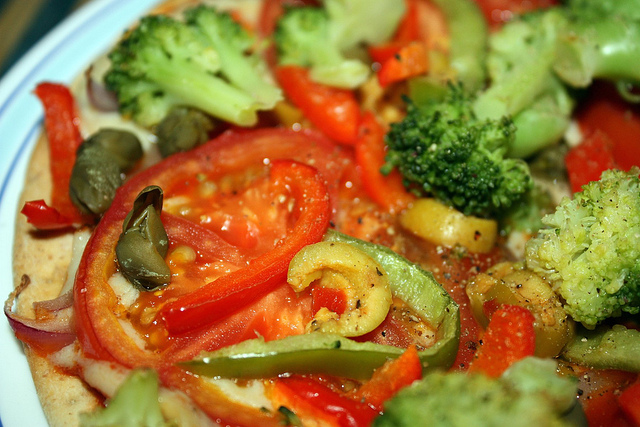How many broccolis are there? Upon reviewing the image, there are exactly three distinguishable broccoli florets visible amidst the other vibrant vegetables. 